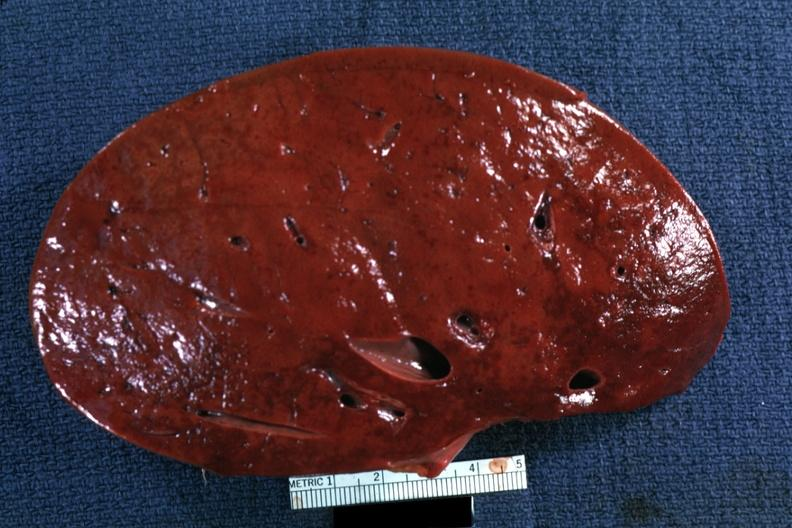s trophic changes present?
Answer the question using a single word or phrase. No 